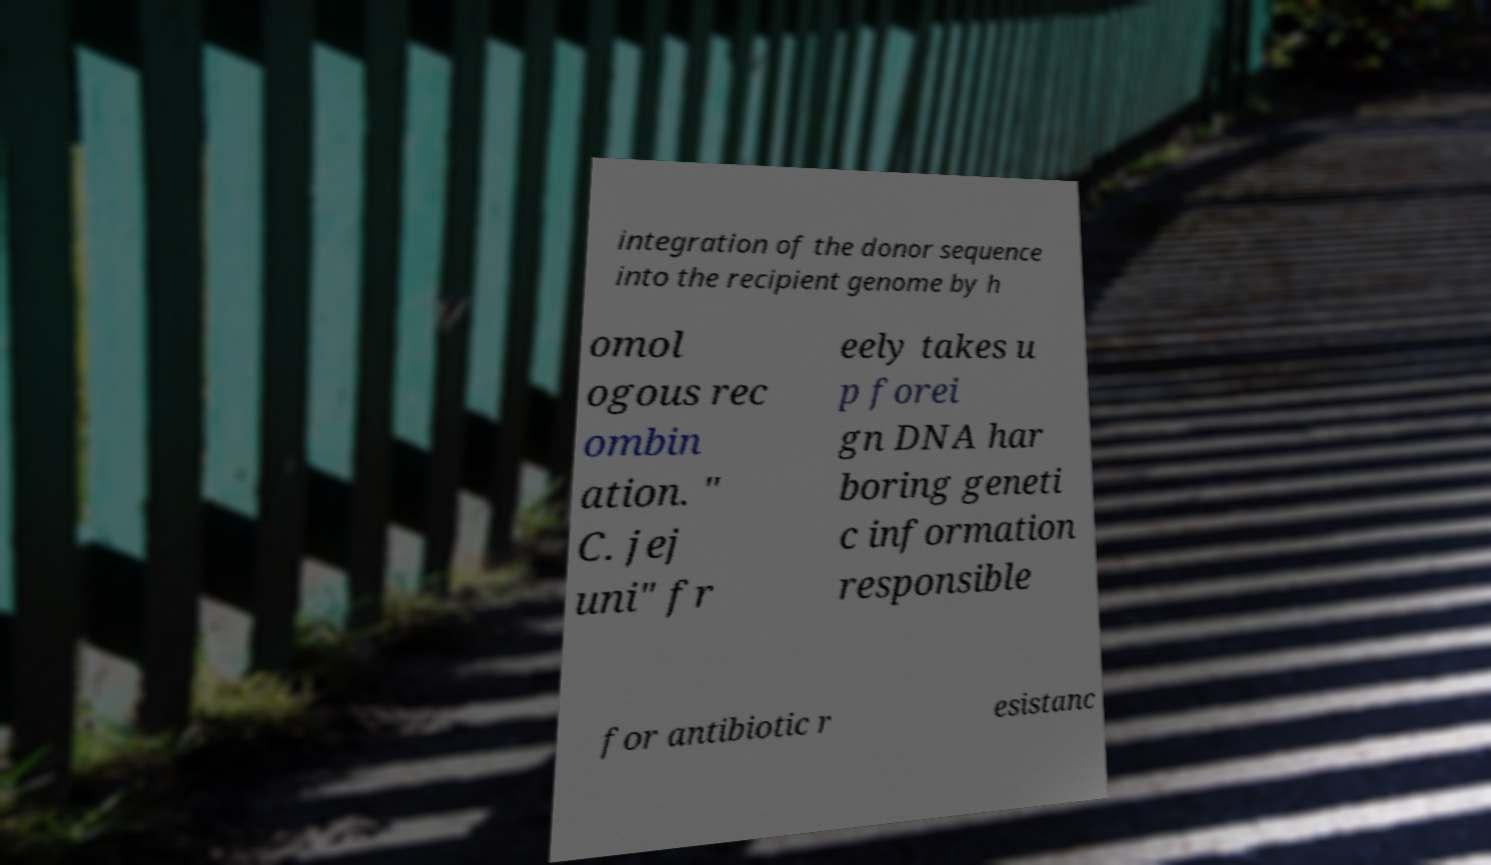Could you extract and type out the text from this image? integration of the donor sequence into the recipient genome by h omol ogous rec ombin ation. " C. jej uni" fr eely takes u p forei gn DNA har boring geneti c information responsible for antibiotic r esistanc 